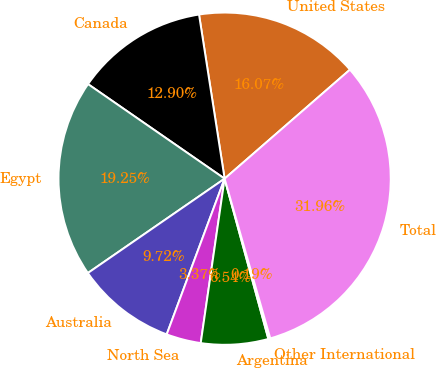<chart> <loc_0><loc_0><loc_500><loc_500><pie_chart><fcel>United States<fcel>Canada<fcel>Egypt<fcel>Australia<fcel>North Sea<fcel>Argentina<fcel>Other International<fcel>Total<nl><fcel>16.07%<fcel>12.9%<fcel>19.25%<fcel>9.72%<fcel>3.37%<fcel>6.54%<fcel>0.19%<fcel>31.96%<nl></chart> 